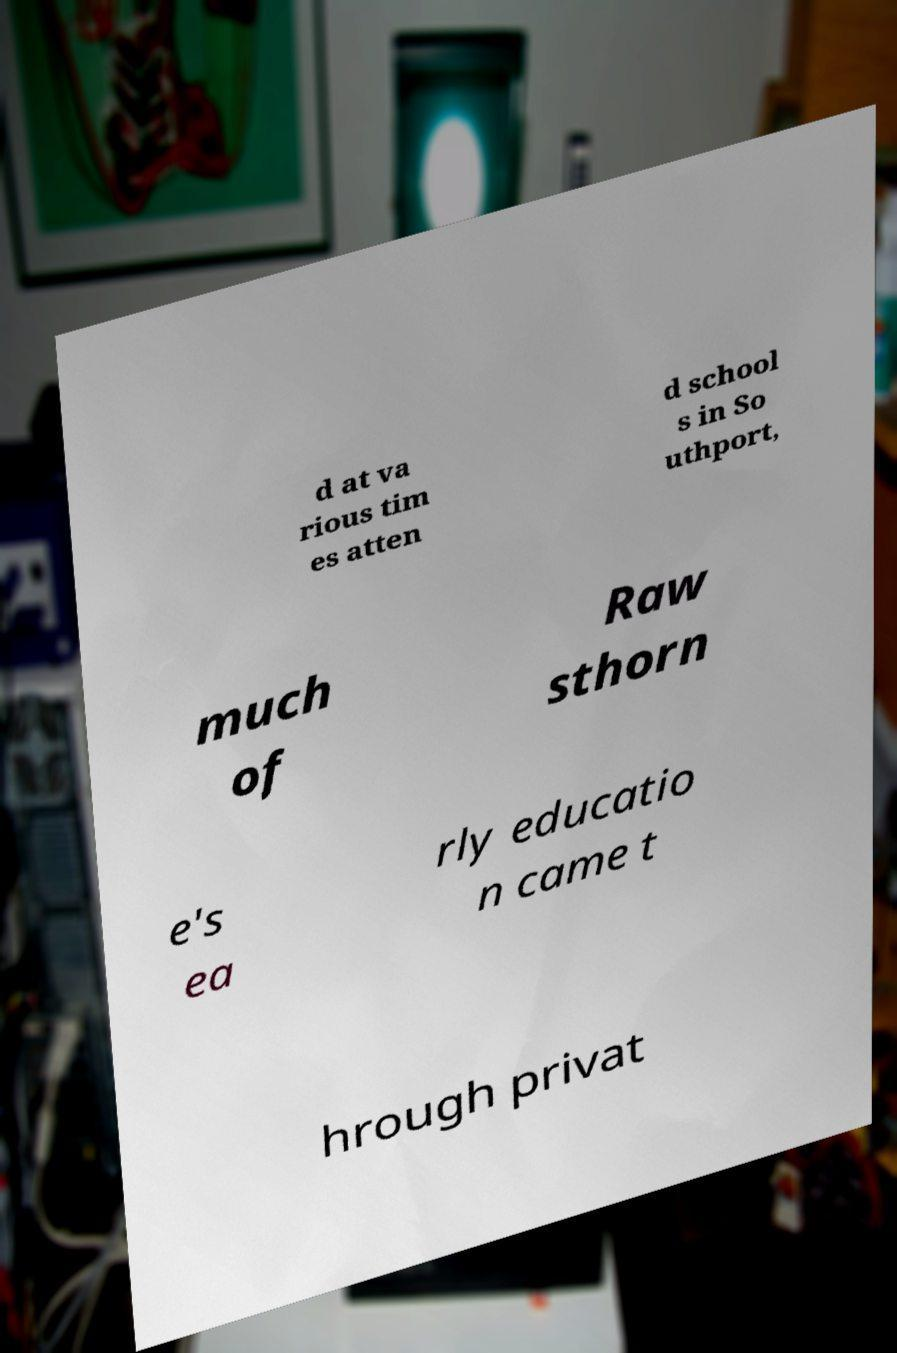Can you read and provide the text displayed in the image?This photo seems to have some interesting text. Can you extract and type it out for me? d at va rious tim es atten d school s in So uthport, much of Raw sthorn e's ea rly educatio n came t hrough privat 